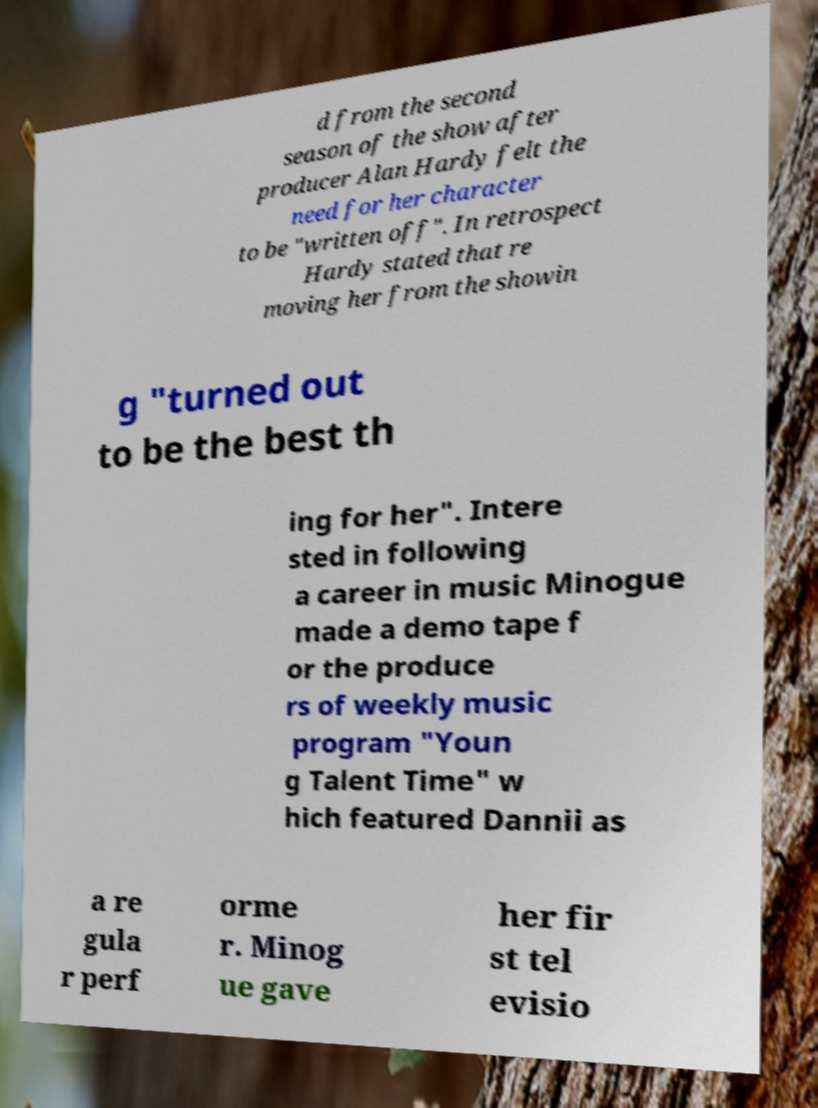For documentation purposes, I need the text within this image transcribed. Could you provide that? d from the second season of the show after producer Alan Hardy felt the need for her character to be "written off". In retrospect Hardy stated that re moving her from the showin g "turned out to be the best th ing for her". Intere sted in following a career in music Minogue made a demo tape f or the produce rs of weekly music program "Youn g Talent Time" w hich featured Dannii as a re gula r perf orme r. Minog ue gave her fir st tel evisio 